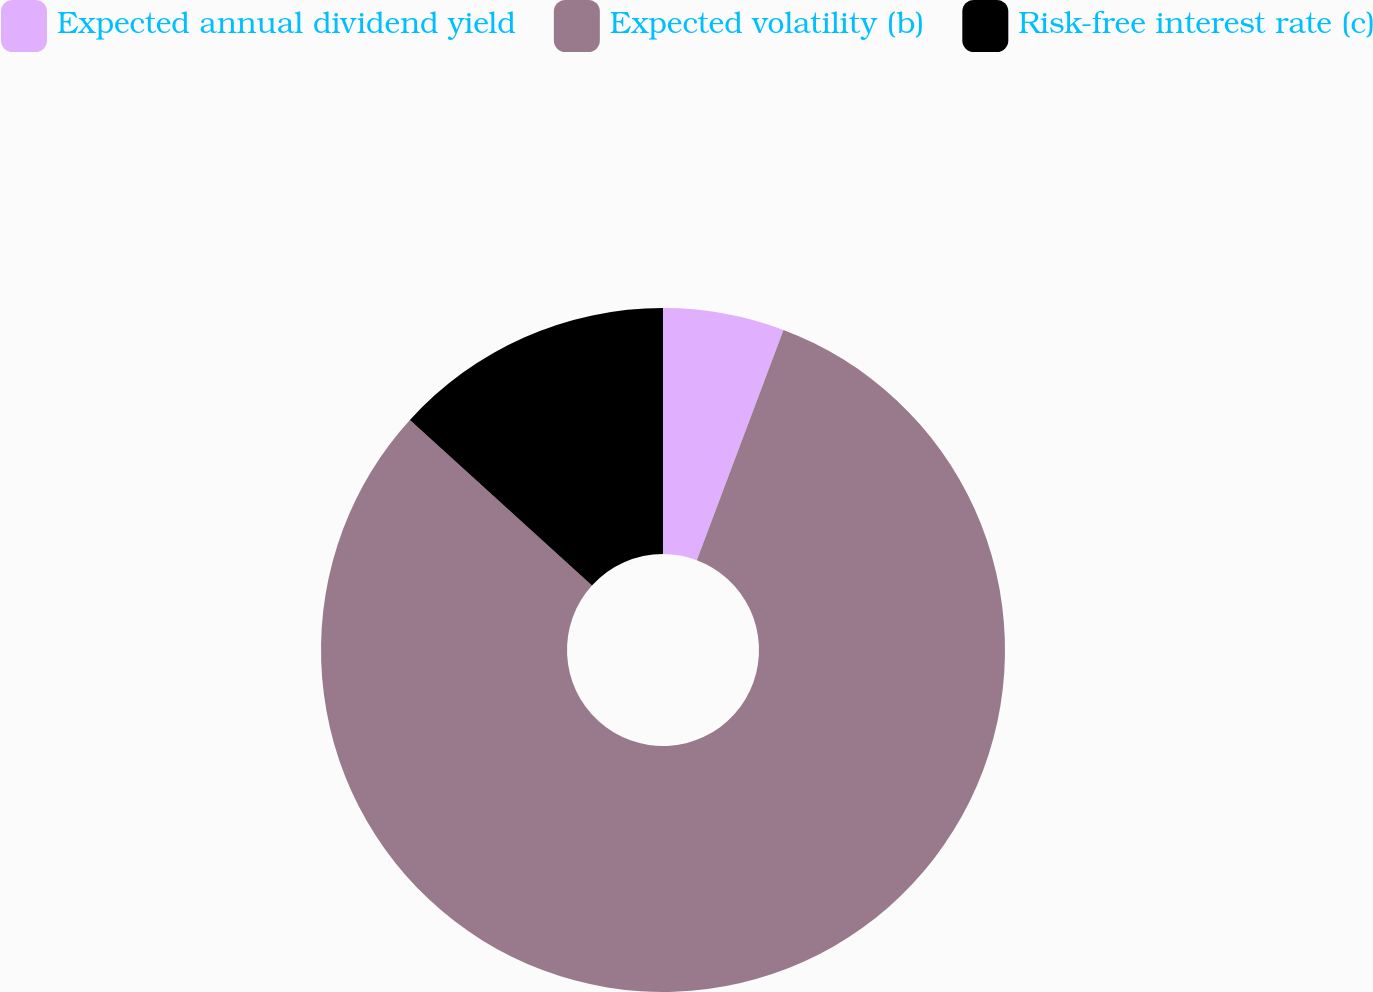Convert chart. <chart><loc_0><loc_0><loc_500><loc_500><pie_chart><fcel>Expected annual dividend yield<fcel>Expected volatility (b)<fcel>Risk-free interest rate (c)<nl><fcel>5.73%<fcel>81.01%<fcel>13.26%<nl></chart> 